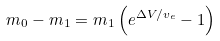<formula> <loc_0><loc_0><loc_500><loc_500>m _ { 0 } - m _ { 1 } = m _ { 1 } \left ( e ^ { \Delta V / v _ { e } } - 1 \right )</formula> 